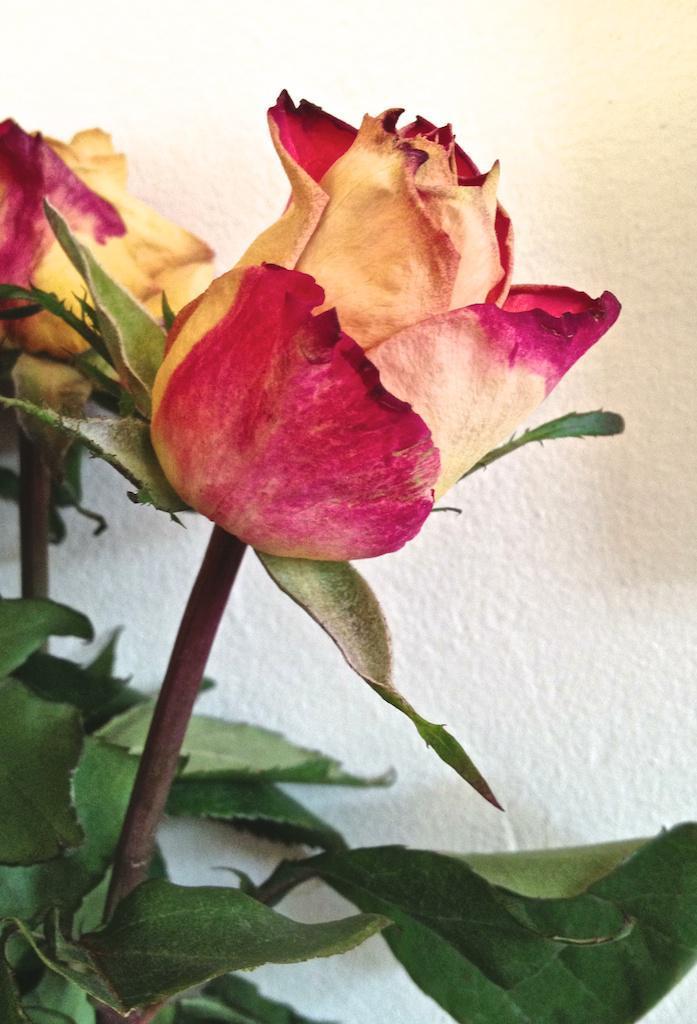In one or two sentences, can you explain what this image depicts? In this image there are two roses with stems and leaves, the background is white. 